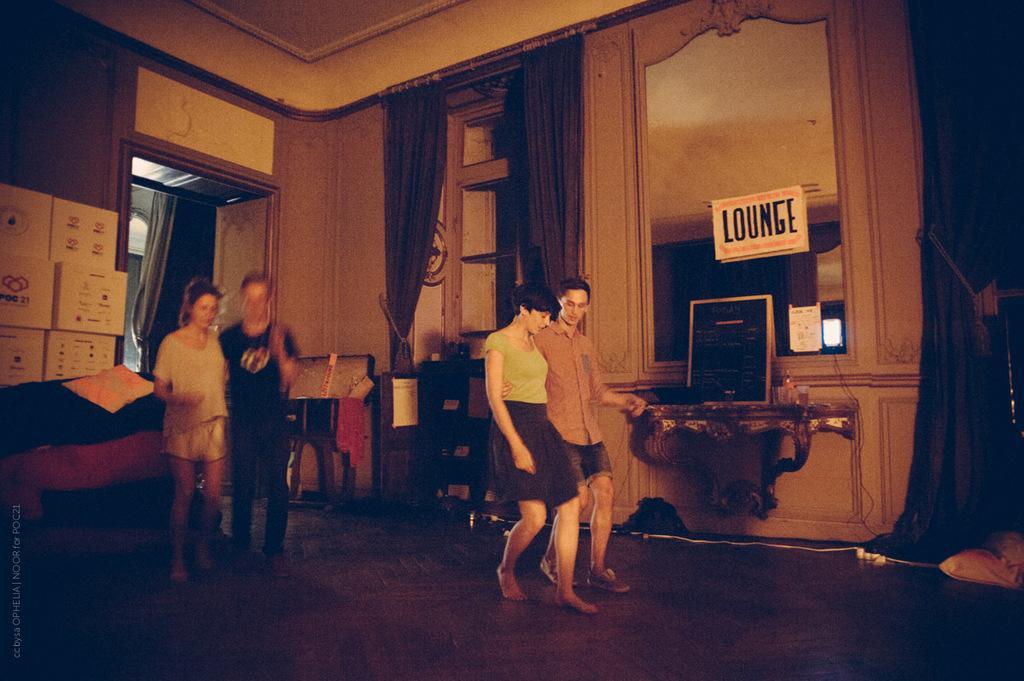Please provide a concise description of this image. In this image we can see few people. There is some reflection on the mirror. There are few objects in the image. There are few boxes at the left side of the image. There are few curtains in the image. There are few posters in the image. 